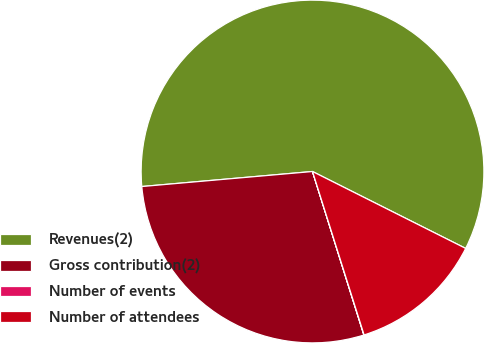Convert chart. <chart><loc_0><loc_0><loc_500><loc_500><pie_chart><fcel>Revenues(2)<fcel>Gross contribution(2)<fcel>Number of events<fcel>Number of attendees<nl><fcel>58.81%<fcel>28.45%<fcel>0.02%<fcel>12.73%<nl></chart> 